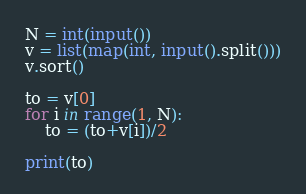Convert code to text. <code><loc_0><loc_0><loc_500><loc_500><_Python_>N = int(input())
v = list(map(int, input().split()))
v.sort()

to = v[0]
for i in range(1, N):
	to = (to+v[i])/2

print(to)

</code> 